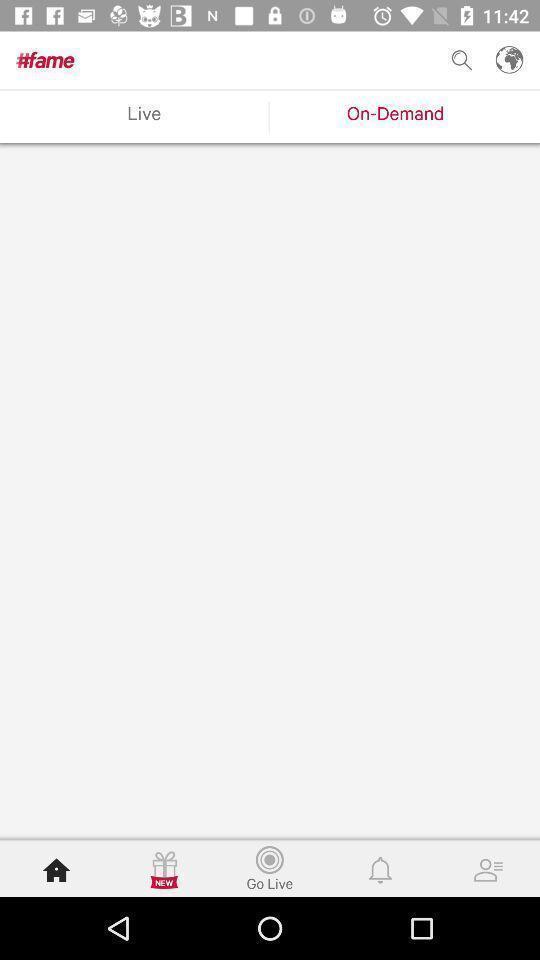Please provide a description for this image. Screen displaying options in entertainment application. 